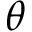Convert formula to latex. <formula><loc_0><loc_0><loc_500><loc_500>\theta</formula> 